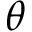Convert formula to latex. <formula><loc_0><loc_0><loc_500><loc_500>\theta</formula> 